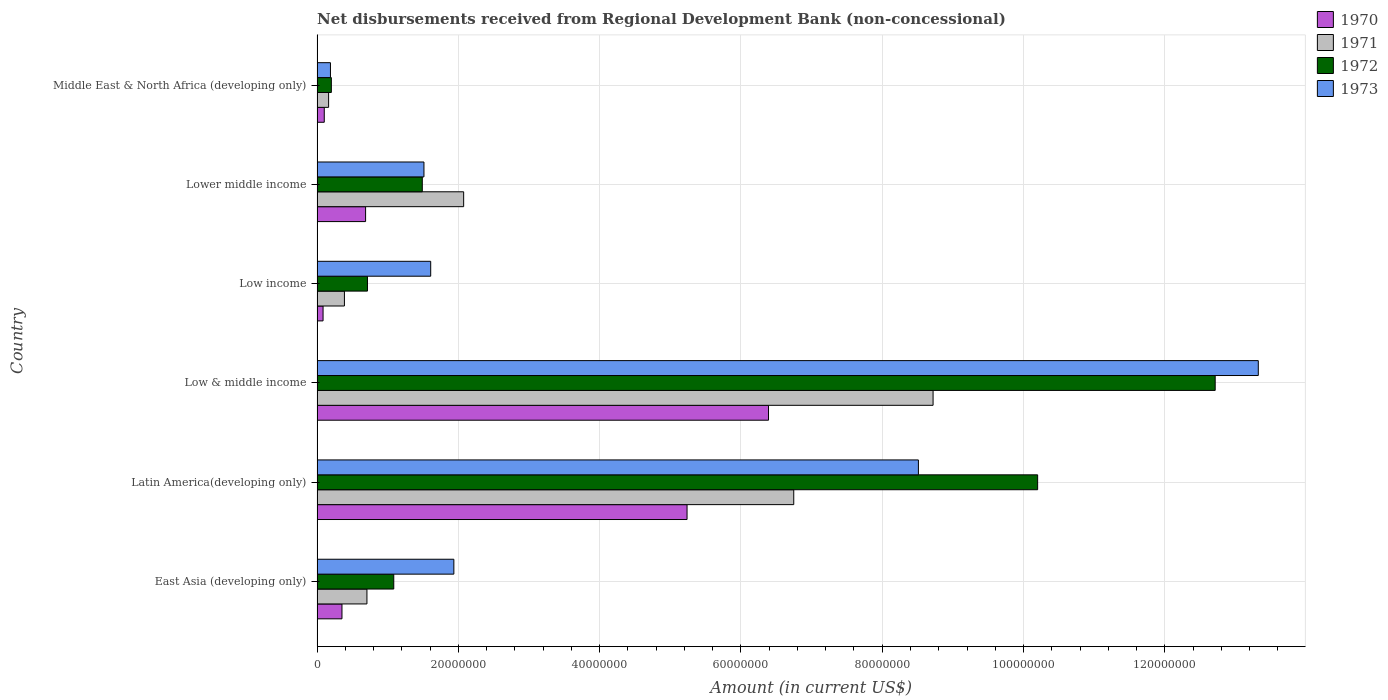How many different coloured bars are there?
Keep it short and to the point. 4. How many groups of bars are there?
Offer a terse response. 6. Are the number of bars on each tick of the Y-axis equal?
Give a very brief answer. Yes. What is the label of the 1st group of bars from the top?
Give a very brief answer. Middle East & North Africa (developing only). What is the amount of disbursements received from Regional Development Bank in 1971 in Latin America(developing only)?
Your answer should be compact. 6.75e+07. Across all countries, what is the maximum amount of disbursements received from Regional Development Bank in 1971?
Make the answer very short. 8.72e+07. Across all countries, what is the minimum amount of disbursements received from Regional Development Bank in 1972?
Ensure brevity in your answer.  2.02e+06. In which country was the amount of disbursements received from Regional Development Bank in 1972 maximum?
Offer a very short reply. Low & middle income. In which country was the amount of disbursements received from Regional Development Bank in 1972 minimum?
Your answer should be very brief. Middle East & North Africa (developing only). What is the total amount of disbursements received from Regional Development Bank in 1972 in the graph?
Provide a succinct answer. 2.64e+08. What is the difference between the amount of disbursements received from Regional Development Bank in 1971 in Low & middle income and that in Lower middle income?
Ensure brevity in your answer.  6.64e+07. What is the difference between the amount of disbursements received from Regional Development Bank in 1971 in Low income and the amount of disbursements received from Regional Development Bank in 1972 in Middle East & North Africa (developing only)?
Ensure brevity in your answer.  1.85e+06. What is the average amount of disbursements received from Regional Development Bank in 1971 per country?
Ensure brevity in your answer.  3.13e+07. What is the difference between the amount of disbursements received from Regional Development Bank in 1973 and amount of disbursements received from Regional Development Bank in 1970 in Low & middle income?
Offer a very short reply. 6.93e+07. What is the ratio of the amount of disbursements received from Regional Development Bank in 1972 in Low income to that in Lower middle income?
Your answer should be very brief. 0.48. What is the difference between the highest and the second highest amount of disbursements received from Regional Development Bank in 1972?
Give a very brief answer. 2.51e+07. What is the difference between the highest and the lowest amount of disbursements received from Regional Development Bank in 1973?
Make the answer very short. 1.31e+08. Is the sum of the amount of disbursements received from Regional Development Bank in 1973 in Low income and Lower middle income greater than the maximum amount of disbursements received from Regional Development Bank in 1970 across all countries?
Make the answer very short. No. What does the 4th bar from the top in Low & middle income represents?
Offer a terse response. 1970. What does the 2nd bar from the bottom in Low income represents?
Give a very brief answer. 1971. Is it the case that in every country, the sum of the amount of disbursements received from Regional Development Bank in 1973 and amount of disbursements received from Regional Development Bank in 1972 is greater than the amount of disbursements received from Regional Development Bank in 1970?
Your answer should be very brief. Yes. Are all the bars in the graph horizontal?
Offer a terse response. Yes. What is the difference between two consecutive major ticks on the X-axis?
Offer a very short reply. 2.00e+07. What is the title of the graph?
Offer a very short reply. Net disbursements received from Regional Development Bank (non-concessional). What is the Amount (in current US$) of 1970 in East Asia (developing only)?
Provide a short and direct response. 3.53e+06. What is the Amount (in current US$) in 1971 in East Asia (developing only)?
Provide a short and direct response. 7.06e+06. What is the Amount (in current US$) in 1972 in East Asia (developing only)?
Provide a short and direct response. 1.09e+07. What is the Amount (in current US$) of 1973 in East Asia (developing only)?
Your response must be concise. 1.94e+07. What is the Amount (in current US$) of 1970 in Latin America(developing only)?
Provide a succinct answer. 5.24e+07. What is the Amount (in current US$) of 1971 in Latin America(developing only)?
Ensure brevity in your answer.  6.75e+07. What is the Amount (in current US$) of 1972 in Latin America(developing only)?
Give a very brief answer. 1.02e+08. What is the Amount (in current US$) in 1973 in Latin America(developing only)?
Keep it short and to the point. 8.51e+07. What is the Amount (in current US$) of 1970 in Low & middle income?
Offer a very short reply. 6.39e+07. What is the Amount (in current US$) of 1971 in Low & middle income?
Offer a terse response. 8.72e+07. What is the Amount (in current US$) in 1972 in Low & middle income?
Your answer should be very brief. 1.27e+08. What is the Amount (in current US$) in 1973 in Low & middle income?
Provide a succinct answer. 1.33e+08. What is the Amount (in current US$) of 1970 in Low income?
Your answer should be very brief. 8.50e+05. What is the Amount (in current US$) in 1971 in Low income?
Ensure brevity in your answer.  3.88e+06. What is the Amount (in current US$) in 1972 in Low income?
Provide a succinct answer. 7.14e+06. What is the Amount (in current US$) of 1973 in Low income?
Offer a terse response. 1.61e+07. What is the Amount (in current US$) of 1970 in Lower middle income?
Ensure brevity in your answer.  6.87e+06. What is the Amount (in current US$) of 1971 in Lower middle income?
Offer a very short reply. 2.08e+07. What is the Amount (in current US$) in 1972 in Lower middle income?
Give a very brief answer. 1.49e+07. What is the Amount (in current US$) of 1973 in Lower middle income?
Make the answer very short. 1.51e+07. What is the Amount (in current US$) of 1970 in Middle East & North Africa (developing only)?
Give a very brief answer. 1.02e+06. What is the Amount (in current US$) of 1971 in Middle East & North Africa (developing only)?
Make the answer very short. 1.64e+06. What is the Amount (in current US$) of 1972 in Middle East & North Africa (developing only)?
Provide a succinct answer. 2.02e+06. What is the Amount (in current US$) of 1973 in Middle East & North Africa (developing only)?
Offer a very short reply. 1.90e+06. Across all countries, what is the maximum Amount (in current US$) in 1970?
Make the answer very short. 6.39e+07. Across all countries, what is the maximum Amount (in current US$) of 1971?
Offer a very short reply. 8.72e+07. Across all countries, what is the maximum Amount (in current US$) in 1972?
Provide a succinct answer. 1.27e+08. Across all countries, what is the maximum Amount (in current US$) of 1973?
Provide a short and direct response. 1.33e+08. Across all countries, what is the minimum Amount (in current US$) in 1970?
Provide a short and direct response. 8.50e+05. Across all countries, what is the minimum Amount (in current US$) in 1971?
Ensure brevity in your answer.  1.64e+06. Across all countries, what is the minimum Amount (in current US$) in 1972?
Make the answer very short. 2.02e+06. Across all countries, what is the minimum Amount (in current US$) of 1973?
Keep it short and to the point. 1.90e+06. What is the total Amount (in current US$) in 1970 in the graph?
Make the answer very short. 1.29e+08. What is the total Amount (in current US$) in 1971 in the graph?
Your answer should be very brief. 1.88e+08. What is the total Amount (in current US$) in 1972 in the graph?
Your response must be concise. 2.64e+08. What is the total Amount (in current US$) of 1973 in the graph?
Your answer should be compact. 2.71e+08. What is the difference between the Amount (in current US$) of 1970 in East Asia (developing only) and that in Latin America(developing only)?
Your answer should be very brief. -4.88e+07. What is the difference between the Amount (in current US$) of 1971 in East Asia (developing only) and that in Latin America(developing only)?
Your answer should be compact. -6.04e+07. What is the difference between the Amount (in current US$) of 1972 in East Asia (developing only) and that in Latin America(developing only)?
Your answer should be very brief. -9.11e+07. What is the difference between the Amount (in current US$) of 1973 in East Asia (developing only) and that in Latin America(developing only)?
Give a very brief answer. -6.58e+07. What is the difference between the Amount (in current US$) of 1970 in East Asia (developing only) and that in Low & middle income?
Your answer should be compact. -6.04e+07. What is the difference between the Amount (in current US$) in 1971 in East Asia (developing only) and that in Low & middle income?
Offer a very short reply. -8.01e+07. What is the difference between the Amount (in current US$) in 1972 in East Asia (developing only) and that in Low & middle income?
Your answer should be compact. -1.16e+08. What is the difference between the Amount (in current US$) of 1973 in East Asia (developing only) and that in Low & middle income?
Keep it short and to the point. -1.14e+08. What is the difference between the Amount (in current US$) of 1970 in East Asia (developing only) and that in Low income?
Give a very brief answer. 2.68e+06. What is the difference between the Amount (in current US$) in 1971 in East Asia (developing only) and that in Low income?
Offer a terse response. 3.19e+06. What is the difference between the Amount (in current US$) of 1972 in East Asia (developing only) and that in Low income?
Give a very brief answer. 3.72e+06. What is the difference between the Amount (in current US$) in 1973 in East Asia (developing only) and that in Low income?
Give a very brief answer. 3.28e+06. What is the difference between the Amount (in current US$) in 1970 in East Asia (developing only) and that in Lower middle income?
Offer a very short reply. -3.34e+06. What is the difference between the Amount (in current US$) of 1971 in East Asia (developing only) and that in Lower middle income?
Ensure brevity in your answer.  -1.37e+07. What is the difference between the Amount (in current US$) of 1972 in East Asia (developing only) and that in Lower middle income?
Your response must be concise. -4.04e+06. What is the difference between the Amount (in current US$) of 1973 in East Asia (developing only) and that in Lower middle income?
Make the answer very short. 4.23e+06. What is the difference between the Amount (in current US$) in 1970 in East Asia (developing only) and that in Middle East & North Africa (developing only)?
Your answer should be very brief. 2.51e+06. What is the difference between the Amount (in current US$) of 1971 in East Asia (developing only) and that in Middle East & North Africa (developing only)?
Keep it short and to the point. 5.43e+06. What is the difference between the Amount (in current US$) in 1972 in East Asia (developing only) and that in Middle East & North Africa (developing only)?
Provide a succinct answer. 8.83e+06. What is the difference between the Amount (in current US$) in 1973 in East Asia (developing only) and that in Middle East & North Africa (developing only)?
Ensure brevity in your answer.  1.75e+07. What is the difference between the Amount (in current US$) of 1970 in Latin America(developing only) and that in Low & middle income?
Keep it short and to the point. -1.15e+07. What is the difference between the Amount (in current US$) of 1971 in Latin America(developing only) and that in Low & middle income?
Offer a terse response. -1.97e+07. What is the difference between the Amount (in current US$) in 1972 in Latin America(developing only) and that in Low & middle income?
Your answer should be compact. -2.51e+07. What is the difference between the Amount (in current US$) in 1973 in Latin America(developing only) and that in Low & middle income?
Your answer should be very brief. -4.81e+07. What is the difference between the Amount (in current US$) in 1970 in Latin America(developing only) and that in Low income?
Offer a very short reply. 5.15e+07. What is the difference between the Amount (in current US$) of 1971 in Latin America(developing only) and that in Low income?
Your answer should be compact. 6.36e+07. What is the difference between the Amount (in current US$) in 1972 in Latin America(developing only) and that in Low income?
Your answer should be very brief. 9.49e+07. What is the difference between the Amount (in current US$) in 1973 in Latin America(developing only) and that in Low income?
Give a very brief answer. 6.90e+07. What is the difference between the Amount (in current US$) of 1970 in Latin America(developing only) and that in Lower middle income?
Provide a short and direct response. 4.55e+07. What is the difference between the Amount (in current US$) in 1971 in Latin America(developing only) and that in Lower middle income?
Offer a very short reply. 4.67e+07. What is the difference between the Amount (in current US$) in 1972 in Latin America(developing only) and that in Lower middle income?
Ensure brevity in your answer.  8.71e+07. What is the difference between the Amount (in current US$) in 1973 in Latin America(developing only) and that in Lower middle income?
Give a very brief answer. 7.00e+07. What is the difference between the Amount (in current US$) of 1970 in Latin America(developing only) and that in Middle East & North Africa (developing only)?
Keep it short and to the point. 5.14e+07. What is the difference between the Amount (in current US$) in 1971 in Latin America(developing only) and that in Middle East & North Africa (developing only)?
Provide a short and direct response. 6.58e+07. What is the difference between the Amount (in current US$) in 1972 in Latin America(developing only) and that in Middle East & North Africa (developing only)?
Your answer should be very brief. 1.00e+08. What is the difference between the Amount (in current US$) in 1973 in Latin America(developing only) and that in Middle East & North Africa (developing only)?
Your answer should be compact. 8.32e+07. What is the difference between the Amount (in current US$) in 1970 in Low & middle income and that in Low income?
Make the answer very short. 6.31e+07. What is the difference between the Amount (in current US$) of 1971 in Low & middle income and that in Low income?
Give a very brief answer. 8.33e+07. What is the difference between the Amount (in current US$) of 1972 in Low & middle income and that in Low income?
Provide a succinct answer. 1.20e+08. What is the difference between the Amount (in current US$) in 1973 in Low & middle income and that in Low income?
Your answer should be very brief. 1.17e+08. What is the difference between the Amount (in current US$) in 1970 in Low & middle income and that in Lower middle income?
Keep it short and to the point. 5.70e+07. What is the difference between the Amount (in current US$) in 1971 in Low & middle income and that in Lower middle income?
Keep it short and to the point. 6.64e+07. What is the difference between the Amount (in current US$) of 1972 in Low & middle income and that in Lower middle income?
Give a very brief answer. 1.12e+08. What is the difference between the Amount (in current US$) in 1973 in Low & middle income and that in Lower middle income?
Your answer should be very brief. 1.18e+08. What is the difference between the Amount (in current US$) in 1970 in Low & middle income and that in Middle East & North Africa (developing only)?
Offer a terse response. 6.29e+07. What is the difference between the Amount (in current US$) of 1971 in Low & middle income and that in Middle East & North Africa (developing only)?
Provide a succinct answer. 8.56e+07. What is the difference between the Amount (in current US$) in 1972 in Low & middle income and that in Middle East & North Africa (developing only)?
Offer a very short reply. 1.25e+08. What is the difference between the Amount (in current US$) in 1973 in Low & middle income and that in Middle East & North Africa (developing only)?
Your response must be concise. 1.31e+08. What is the difference between the Amount (in current US$) of 1970 in Low income and that in Lower middle income?
Provide a short and direct response. -6.02e+06. What is the difference between the Amount (in current US$) in 1971 in Low income and that in Lower middle income?
Provide a succinct answer. -1.69e+07. What is the difference between the Amount (in current US$) of 1972 in Low income and that in Lower middle income?
Ensure brevity in your answer.  -7.76e+06. What is the difference between the Amount (in current US$) of 1973 in Low income and that in Lower middle income?
Provide a succinct answer. 9.55e+05. What is the difference between the Amount (in current US$) in 1970 in Low income and that in Middle East & North Africa (developing only)?
Give a very brief answer. -1.71e+05. What is the difference between the Amount (in current US$) in 1971 in Low income and that in Middle East & North Africa (developing only)?
Offer a terse response. 2.24e+06. What is the difference between the Amount (in current US$) of 1972 in Low income and that in Middle East & North Africa (developing only)?
Offer a terse response. 5.11e+06. What is the difference between the Amount (in current US$) of 1973 in Low income and that in Middle East & North Africa (developing only)?
Provide a short and direct response. 1.42e+07. What is the difference between the Amount (in current US$) of 1970 in Lower middle income and that in Middle East & North Africa (developing only)?
Make the answer very short. 5.85e+06. What is the difference between the Amount (in current US$) in 1971 in Lower middle income and that in Middle East & North Africa (developing only)?
Give a very brief answer. 1.91e+07. What is the difference between the Amount (in current US$) in 1972 in Lower middle income and that in Middle East & North Africa (developing only)?
Your response must be concise. 1.29e+07. What is the difference between the Amount (in current US$) in 1973 in Lower middle income and that in Middle East & North Africa (developing only)?
Provide a short and direct response. 1.32e+07. What is the difference between the Amount (in current US$) in 1970 in East Asia (developing only) and the Amount (in current US$) in 1971 in Latin America(developing only)?
Your response must be concise. -6.39e+07. What is the difference between the Amount (in current US$) of 1970 in East Asia (developing only) and the Amount (in current US$) of 1972 in Latin America(developing only)?
Keep it short and to the point. -9.85e+07. What is the difference between the Amount (in current US$) of 1970 in East Asia (developing only) and the Amount (in current US$) of 1973 in Latin America(developing only)?
Your answer should be very brief. -8.16e+07. What is the difference between the Amount (in current US$) of 1971 in East Asia (developing only) and the Amount (in current US$) of 1972 in Latin America(developing only)?
Your answer should be very brief. -9.49e+07. What is the difference between the Amount (in current US$) of 1971 in East Asia (developing only) and the Amount (in current US$) of 1973 in Latin America(developing only)?
Your answer should be very brief. -7.81e+07. What is the difference between the Amount (in current US$) in 1972 in East Asia (developing only) and the Amount (in current US$) in 1973 in Latin America(developing only)?
Your answer should be very brief. -7.43e+07. What is the difference between the Amount (in current US$) in 1970 in East Asia (developing only) and the Amount (in current US$) in 1971 in Low & middle income?
Your answer should be compact. -8.37e+07. What is the difference between the Amount (in current US$) in 1970 in East Asia (developing only) and the Amount (in current US$) in 1972 in Low & middle income?
Offer a terse response. -1.24e+08. What is the difference between the Amount (in current US$) in 1970 in East Asia (developing only) and the Amount (in current US$) in 1973 in Low & middle income?
Your response must be concise. -1.30e+08. What is the difference between the Amount (in current US$) in 1971 in East Asia (developing only) and the Amount (in current US$) in 1972 in Low & middle income?
Keep it short and to the point. -1.20e+08. What is the difference between the Amount (in current US$) of 1971 in East Asia (developing only) and the Amount (in current US$) of 1973 in Low & middle income?
Your answer should be compact. -1.26e+08. What is the difference between the Amount (in current US$) in 1972 in East Asia (developing only) and the Amount (in current US$) in 1973 in Low & middle income?
Give a very brief answer. -1.22e+08. What is the difference between the Amount (in current US$) of 1970 in East Asia (developing only) and the Amount (in current US$) of 1971 in Low income?
Make the answer very short. -3.48e+05. What is the difference between the Amount (in current US$) in 1970 in East Asia (developing only) and the Amount (in current US$) in 1972 in Low income?
Ensure brevity in your answer.  -3.61e+06. What is the difference between the Amount (in current US$) of 1970 in East Asia (developing only) and the Amount (in current US$) of 1973 in Low income?
Give a very brief answer. -1.26e+07. What is the difference between the Amount (in current US$) in 1971 in East Asia (developing only) and the Amount (in current US$) in 1972 in Low income?
Offer a terse response. -7.50e+04. What is the difference between the Amount (in current US$) in 1971 in East Asia (developing only) and the Amount (in current US$) in 1973 in Low income?
Provide a short and direct response. -9.03e+06. What is the difference between the Amount (in current US$) of 1972 in East Asia (developing only) and the Amount (in current US$) of 1973 in Low income?
Provide a short and direct response. -5.23e+06. What is the difference between the Amount (in current US$) in 1970 in East Asia (developing only) and the Amount (in current US$) in 1971 in Lower middle income?
Offer a terse response. -1.72e+07. What is the difference between the Amount (in current US$) of 1970 in East Asia (developing only) and the Amount (in current US$) of 1972 in Lower middle income?
Provide a succinct answer. -1.14e+07. What is the difference between the Amount (in current US$) in 1970 in East Asia (developing only) and the Amount (in current US$) in 1973 in Lower middle income?
Give a very brief answer. -1.16e+07. What is the difference between the Amount (in current US$) of 1971 in East Asia (developing only) and the Amount (in current US$) of 1972 in Lower middle income?
Ensure brevity in your answer.  -7.84e+06. What is the difference between the Amount (in current US$) of 1971 in East Asia (developing only) and the Amount (in current US$) of 1973 in Lower middle income?
Offer a very short reply. -8.07e+06. What is the difference between the Amount (in current US$) of 1972 in East Asia (developing only) and the Amount (in current US$) of 1973 in Lower middle income?
Your response must be concise. -4.28e+06. What is the difference between the Amount (in current US$) in 1970 in East Asia (developing only) and the Amount (in current US$) in 1971 in Middle East & North Africa (developing only)?
Make the answer very short. 1.89e+06. What is the difference between the Amount (in current US$) of 1970 in East Asia (developing only) and the Amount (in current US$) of 1972 in Middle East & North Africa (developing only)?
Make the answer very short. 1.50e+06. What is the difference between the Amount (in current US$) of 1970 in East Asia (developing only) and the Amount (in current US$) of 1973 in Middle East & North Africa (developing only)?
Give a very brief answer. 1.63e+06. What is the difference between the Amount (in current US$) in 1971 in East Asia (developing only) and the Amount (in current US$) in 1972 in Middle East & North Africa (developing only)?
Your answer should be compact. 5.04e+06. What is the difference between the Amount (in current US$) in 1971 in East Asia (developing only) and the Amount (in current US$) in 1973 in Middle East & North Africa (developing only)?
Give a very brief answer. 5.17e+06. What is the difference between the Amount (in current US$) of 1972 in East Asia (developing only) and the Amount (in current US$) of 1973 in Middle East & North Africa (developing only)?
Give a very brief answer. 8.96e+06. What is the difference between the Amount (in current US$) in 1970 in Latin America(developing only) and the Amount (in current US$) in 1971 in Low & middle income?
Provide a short and direct response. -3.48e+07. What is the difference between the Amount (in current US$) in 1970 in Latin America(developing only) and the Amount (in current US$) in 1972 in Low & middle income?
Give a very brief answer. -7.48e+07. What is the difference between the Amount (in current US$) in 1970 in Latin America(developing only) and the Amount (in current US$) in 1973 in Low & middle income?
Give a very brief answer. -8.09e+07. What is the difference between the Amount (in current US$) in 1971 in Latin America(developing only) and the Amount (in current US$) in 1972 in Low & middle income?
Offer a terse response. -5.97e+07. What is the difference between the Amount (in current US$) in 1971 in Latin America(developing only) and the Amount (in current US$) in 1973 in Low & middle income?
Offer a very short reply. -6.58e+07. What is the difference between the Amount (in current US$) in 1972 in Latin America(developing only) and the Amount (in current US$) in 1973 in Low & middle income?
Make the answer very short. -3.12e+07. What is the difference between the Amount (in current US$) of 1970 in Latin America(developing only) and the Amount (in current US$) of 1971 in Low income?
Make the answer very short. 4.85e+07. What is the difference between the Amount (in current US$) of 1970 in Latin America(developing only) and the Amount (in current US$) of 1972 in Low income?
Offer a terse response. 4.52e+07. What is the difference between the Amount (in current US$) in 1970 in Latin America(developing only) and the Amount (in current US$) in 1973 in Low income?
Your answer should be very brief. 3.63e+07. What is the difference between the Amount (in current US$) of 1971 in Latin America(developing only) and the Amount (in current US$) of 1972 in Low income?
Your response must be concise. 6.03e+07. What is the difference between the Amount (in current US$) in 1971 in Latin America(developing only) and the Amount (in current US$) in 1973 in Low income?
Offer a terse response. 5.14e+07. What is the difference between the Amount (in current US$) in 1972 in Latin America(developing only) and the Amount (in current US$) in 1973 in Low income?
Your response must be concise. 8.59e+07. What is the difference between the Amount (in current US$) in 1970 in Latin America(developing only) and the Amount (in current US$) in 1971 in Lower middle income?
Ensure brevity in your answer.  3.16e+07. What is the difference between the Amount (in current US$) of 1970 in Latin America(developing only) and the Amount (in current US$) of 1972 in Lower middle income?
Your response must be concise. 3.75e+07. What is the difference between the Amount (in current US$) of 1970 in Latin America(developing only) and the Amount (in current US$) of 1973 in Lower middle income?
Your answer should be compact. 3.72e+07. What is the difference between the Amount (in current US$) in 1971 in Latin America(developing only) and the Amount (in current US$) in 1972 in Lower middle income?
Provide a short and direct response. 5.26e+07. What is the difference between the Amount (in current US$) of 1971 in Latin America(developing only) and the Amount (in current US$) of 1973 in Lower middle income?
Keep it short and to the point. 5.23e+07. What is the difference between the Amount (in current US$) in 1972 in Latin America(developing only) and the Amount (in current US$) in 1973 in Lower middle income?
Offer a very short reply. 8.69e+07. What is the difference between the Amount (in current US$) in 1970 in Latin America(developing only) and the Amount (in current US$) in 1971 in Middle East & North Africa (developing only)?
Offer a terse response. 5.07e+07. What is the difference between the Amount (in current US$) in 1970 in Latin America(developing only) and the Amount (in current US$) in 1972 in Middle East & North Africa (developing only)?
Make the answer very short. 5.04e+07. What is the difference between the Amount (in current US$) in 1970 in Latin America(developing only) and the Amount (in current US$) in 1973 in Middle East & North Africa (developing only)?
Give a very brief answer. 5.05e+07. What is the difference between the Amount (in current US$) of 1971 in Latin America(developing only) and the Amount (in current US$) of 1972 in Middle East & North Africa (developing only)?
Offer a very short reply. 6.55e+07. What is the difference between the Amount (in current US$) of 1971 in Latin America(developing only) and the Amount (in current US$) of 1973 in Middle East & North Africa (developing only)?
Ensure brevity in your answer.  6.56e+07. What is the difference between the Amount (in current US$) of 1972 in Latin America(developing only) and the Amount (in current US$) of 1973 in Middle East & North Africa (developing only)?
Make the answer very short. 1.00e+08. What is the difference between the Amount (in current US$) of 1970 in Low & middle income and the Amount (in current US$) of 1971 in Low income?
Provide a short and direct response. 6.00e+07. What is the difference between the Amount (in current US$) of 1970 in Low & middle income and the Amount (in current US$) of 1972 in Low income?
Your response must be concise. 5.68e+07. What is the difference between the Amount (in current US$) of 1970 in Low & middle income and the Amount (in current US$) of 1973 in Low income?
Offer a terse response. 4.78e+07. What is the difference between the Amount (in current US$) in 1971 in Low & middle income and the Amount (in current US$) in 1972 in Low income?
Offer a very short reply. 8.01e+07. What is the difference between the Amount (in current US$) in 1971 in Low & middle income and the Amount (in current US$) in 1973 in Low income?
Provide a succinct answer. 7.11e+07. What is the difference between the Amount (in current US$) in 1972 in Low & middle income and the Amount (in current US$) in 1973 in Low income?
Make the answer very short. 1.11e+08. What is the difference between the Amount (in current US$) in 1970 in Low & middle income and the Amount (in current US$) in 1971 in Lower middle income?
Provide a short and direct response. 4.32e+07. What is the difference between the Amount (in current US$) in 1970 in Low & middle income and the Amount (in current US$) in 1972 in Lower middle income?
Offer a terse response. 4.90e+07. What is the difference between the Amount (in current US$) in 1970 in Low & middle income and the Amount (in current US$) in 1973 in Lower middle income?
Offer a terse response. 4.88e+07. What is the difference between the Amount (in current US$) of 1971 in Low & middle income and the Amount (in current US$) of 1972 in Lower middle income?
Keep it short and to the point. 7.23e+07. What is the difference between the Amount (in current US$) of 1971 in Low & middle income and the Amount (in current US$) of 1973 in Lower middle income?
Make the answer very short. 7.21e+07. What is the difference between the Amount (in current US$) of 1972 in Low & middle income and the Amount (in current US$) of 1973 in Lower middle income?
Your answer should be compact. 1.12e+08. What is the difference between the Amount (in current US$) in 1970 in Low & middle income and the Amount (in current US$) in 1971 in Middle East & North Africa (developing only)?
Your response must be concise. 6.23e+07. What is the difference between the Amount (in current US$) in 1970 in Low & middle income and the Amount (in current US$) in 1972 in Middle East & North Africa (developing only)?
Your response must be concise. 6.19e+07. What is the difference between the Amount (in current US$) of 1970 in Low & middle income and the Amount (in current US$) of 1973 in Middle East & North Africa (developing only)?
Offer a terse response. 6.20e+07. What is the difference between the Amount (in current US$) of 1971 in Low & middle income and the Amount (in current US$) of 1972 in Middle East & North Africa (developing only)?
Ensure brevity in your answer.  8.52e+07. What is the difference between the Amount (in current US$) of 1971 in Low & middle income and the Amount (in current US$) of 1973 in Middle East & North Africa (developing only)?
Your answer should be compact. 8.53e+07. What is the difference between the Amount (in current US$) of 1972 in Low & middle income and the Amount (in current US$) of 1973 in Middle East & North Africa (developing only)?
Offer a very short reply. 1.25e+08. What is the difference between the Amount (in current US$) in 1970 in Low income and the Amount (in current US$) in 1971 in Lower middle income?
Give a very brief answer. -1.99e+07. What is the difference between the Amount (in current US$) of 1970 in Low income and the Amount (in current US$) of 1972 in Lower middle income?
Your answer should be very brief. -1.40e+07. What is the difference between the Amount (in current US$) in 1970 in Low income and the Amount (in current US$) in 1973 in Lower middle income?
Offer a very short reply. -1.43e+07. What is the difference between the Amount (in current US$) of 1971 in Low income and the Amount (in current US$) of 1972 in Lower middle income?
Make the answer very short. -1.10e+07. What is the difference between the Amount (in current US$) in 1971 in Low income and the Amount (in current US$) in 1973 in Lower middle income?
Keep it short and to the point. -1.13e+07. What is the difference between the Amount (in current US$) of 1972 in Low income and the Amount (in current US$) of 1973 in Lower middle income?
Ensure brevity in your answer.  -8.00e+06. What is the difference between the Amount (in current US$) in 1970 in Low income and the Amount (in current US$) in 1971 in Middle East & North Africa (developing only)?
Ensure brevity in your answer.  -7.85e+05. What is the difference between the Amount (in current US$) in 1970 in Low income and the Amount (in current US$) in 1972 in Middle East & North Africa (developing only)?
Provide a succinct answer. -1.17e+06. What is the difference between the Amount (in current US$) in 1970 in Low income and the Amount (in current US$) in 1973 in Middle East & North Africa (developing only)?
Ensure brevity in your answer.  -1.05e+06. What is the difference between the Amount (in current US$) in 1971 in Low income and the Amount (in current US$) in 1972 in Middle East & North Africa (developing only)?
Offer a terse response. 1.85e+06. What is the difference between the Amount (in current US$) in 1971 in Low income and the Amount (in current US$) in 1973 in Middle East & North Africa (developing only)?
Ensure brevity in your answer.  1.98e+06. What is the difference between the Amount (in current US$) in 1972 in Low income and the Amount (in current US$) in 1973 in Middle East & North Africa (developing only)?
Keep it short and to the point. 5.24e+06. What is the difference between the Amount (in current US$) in 1970 in Lower middle income and the Amount (in current US$) in 1971 in Middle East & North Africa (developing only)?
Make the answer very short. 5.24e+06. What is the difference between the Amount (in current US$) in 1970 in Lower middle income and the Amount (in current US$) in 1972 in Middle East & North Africa (developing only)?
Provide a succinct answer. 4.85e+06. What is the difference between the Amount (in current US$) of 1970 in Lower middle income and the Amount (in current US$) of 1973 in Middle East & North Africa (developing only)?
Keep it short and to the point. 4.98e+06. What is the difference between the Amount (in current US$) of 1971 in Lower middle income and the Amount (in current US$) of 1972 in Middle East & North Africa (developing only)?
Your response must be concise. 1.87e+07. What is the difference between the Amount (in current US$) of 1971 in Lower middle income and the Amount (in current US$) of 1973 in Middle East & North Africa (developing only)?
Provide a short and direct response. 1.89e+07. What is the difference between the Amount (in current US$) of 1972 in Lower middle income and the Amount (in current US$) of 1973 in Middle East & North Africa (developing only)?
Keep it short and to the point. 1.30e+07. What is the average Amount (in current US$) of 1970 per country?
Provide a short and direct response. 2.14e+07. What is the average Amount (in current US$) in 1971 per country?
Your answer should be compact. 3.13e+07. What is the average Amount (in current US$) in 1972 per country?
Provide a short and direct response. 4.40e+07. What is the average Amount (in current US$) in 1973 per country?
Your answer should be compact. 4.51e+07. What is the difference between the Amount (in current US$) of 1970 and Amount (in current US$) of 1971 in East Asia (developing only)?
Your answer should be compact. -3.54e+06. What is the difference between the Amount (in current US$) of 1970 and Amount (in current US$) of 1972 in East Asia (developing only)?
Provide a short and direct response. -7.33e+06. What is the difference between the Amount (in current US$) in 1970 and Amount (in current US$) in 1973 in East Asia (developing only)?
Give a very brief answer. -1.58e+07. What is the difference between the Amount (in current US$) in 1971 and Amount (in current US$) in 1972 in East Asia (developing only)?
Provide a succinct answer. -3.80e+06. What is the difference between the Amount (in current US$) of 1971 and Amount (in current US$) of 1973 in East Asia (developing only)?
Give a very brief answer. -1.23e+07. What is the difference between the Amount (in current US$) of 1972 and Amount (in current US$) of 1973 in East Asia (developing only)?
Offer a very short reply. -8.51e+06. What is the difference between the Amount (in current US$) of 1970 and Amount (in current US$) of 1971 in Latin America(developing only)?
Offer a terse response. -1.51e+07. What is the difference between the Amount (in current US$) in 1970 and Amount (in current US$) in 1972 in Latin America(developing only)?
Ensure brevity in your answer.  -4.96e+07. What is the difference between the Amount (in current US$) of 1970 and Amount (in current US$) of 1973 in Latin America(developing only)?
Your response must be concise. -3.27e+07. What is the difference between the Amount (in current US$) of 1971 and Amount (in current US$) of 1972 in Latin America(developing only)?
Make the answer very short. -3.45e+07. What is the difference between the Amount (in current US$) of 1971 and Amount (in current US$) of 1973 in Latin America(developing only)?
Ensure brevity in your answer.  -1.76e+07. What is the difference between the Amount (in current US$) in 1972 and Amount (in current US$) in 1973 in Latin America(developing only)?
Provide a short and direct response. 1.69e+07. What is the difference between the Amount (in current US$) in 1970 and Amount (in current US$) in 1971 in Low & middle income?
Offer a terse response. -2.33e+07. What is the difference between the Amount (in current US$) in 1970 and Amount (in current US$) in 1972 in Low & middle income?
Offer a terse response. -6.32e+07. What is the difference between the Amount (in current US$) in 1970 and Amount (in current US$) in 1973 in Low & middle income?
Your answer should be very brief. -6.93e+07. What is the difference between the Amount (in current US$) in 1971 and Amount (in current US$) in 1972 in Low & middle income?
Make the answer very short. -3.99e+07. What is the difference between the Amount (in current US$) in 1971 and Amount (in current US$) in 1973 in Low & middle income?
Ensure brevity in your answer.  -4.60e+07. What is the difference between the Amount (in current US$) of 1972 and Amount (in current US$) of 1973 in Low & middle income?
Ensure brevity in your answer.  -6.10e+06. What is the difference between the Amount (in current US$) of 1970 and Amount (in current US$) of 1971 in Low income?
Ensure brevity in your answer.  -3.02e+06. What is the difference between the Amount (in current US$) in 1970 and Amount (in current US$) in 1972 in Low income?
Your answer should be compact. -6.29e+06. What is the difference between the Amount (in current US$) of 1970 and Amount (in current US$) of 1973 in Low income?
Your answer should be compact. -1.52e+07. What is the difference between the Amount (in current US$) in 1971 and Amount (in current US$) in 1972 in Low income?
Your answer should be very brief. -3.26e+06. What is the difference between the Amount (in current US$) in 1971 and Amount (in current US$) in 1973 in Low income?
Provide a short and direct response. -1.22e+07. What is the difference between the Amount (in current US$) of 1972 and Amount (in current US$) of 1973 in Low income?
Offer a terse response. -8.95e+06. What is the difference between the Amount (in current US$) of 1970 and Amount (in current US$) of 1971 in Lower middle income?
Ensure brevity in your answer.  -1.39e+07. What is the difference between the Amount (in current US$) of 1970 and Amount (in current US$) of 1972 in Lower middle income?
Provide a short and direct response. -8.03e+06. What is the difference between the Amount (in current US$) in 1970 and Amount (in current US$) in 1973 in Lower middle income?
Provide a succinct answer. -8.26e+06. What is the difference between the Amount (in current US$) of 1971 and Amount (in current US$) of 1972 in Lower middle income?
Your response must be concise. 5.85e+06. What is the difference between the Amount (in current US$) in 1971 and Amount (in current US$) in 1973 in Lower middle income?
Provide a succinct answer. 5.62e+06. What is the difference between the Amount (in current US$) in 1972 and Amount (in current US$) in 1973 in Lower middle income?
Your response must be concise. -2.36e+05. What is the difference between the Amount (in current US$) of 1970 and Amount (in current US$) of 1971 in Middle East & North Africa (developing only)?
Your answer should be very brief. -6.14e+05. What is the difference between the Amount (in current US$) of 1970 and Amount (in current US$) of 1972 in Middle East & North Africa (developing only)?
Provide a short and direct response. -1.00e+06. What is the difference between the Amount (in current US$) of 1970 and Amount (in current US$) of 1973 in Middle East & North Africa (developing only)?
Your answer should be compact. -8.75e+05. What is the difference between the Amount (in current US$) of 1971 and Amount (in current US$) of 1972 in Middle East & North Africa (developing only)?
Give a very brief answer. -3.89e+05. What is the difference between the Amount (in current US$) of 1971 and Amount (in current US$) of 1973 in Middle East & North Africa (developing only)?
Offer a terse response. -2.61e+05. What is the difference between the Amount (in current US$) in 1972 and Amount (in current US$) in 1973 in Middle East & North Africa (developing only)?
Give a very brief answer. 1.28e+05. What is the ratio of the Amount (in current US$) of 1970 in East Asia (developing only) to that in Latin America(developing only)?
Keep it short and to the point. 0.07. What is the ratio of the Amount (in current US$) of 1971 in East Asia (developing only) to that in Latin America(developing only)?
Your answer should be very brief. 0.1. What is the ratio of the Amount (in current US$) in 1972 in East Asia (developing only) to that in Latin America(developing only)?
Your answer should be very brief. 0.11. What is the ratio of the Amount (in current US$) of 1973 in East Asia (developing only) to that in Latin America(developing only)?
Provide a short and direct response. 0.23. What is the ratio of the Amount (in current US$) in 1970 in East Asia (developing only) to that in Low & middle income?
Offer a very short reply. 0.06. What is the ratio of the Amount (in current US$) of 1971 in East Asia (developing only) to that in Low & middle income?
Provide a short and direct response. 0.08. What is the ratio of the Amount (in current US$) in 1972 in East Asia (developing only) to that in Low & middle income?
Your response must be concise. 0.09. What is the ratio of the Amount (in current US$) of 1973 in East Asia (developing only) to that in Low & middle income?
Offer a terse response. 0.15. What is the ratio of the Amount (in current US$) of 1970 in East Asia (developing only) to that in Low income?
Give a very brief answer. 4.15. What is the ratio of the Amount (in current US$) of 1971 in East Asia (developing only) to that in Low income?
Offer a very short reply. 1.82. What is the ratio of the Amount (in current US$) of 1972 in East Asia (developing only) to that in Low income?
Provide a succinct answer. 1.52. What is the ratio of the Amount (in current US$) of 1973 in East Asia (developing only) to that in Low income?
Make the answer very short. 1.2. What is the ratio of the Amount (in current US$) in 1970 in East Asia (developing only) to that in Lower middle income?
Provide a succinct answer. 0.51. What is the ratio of the Amount (in current US$) in 1971 in East Asia (developing only) to that in Lower middle income?
Give a very brief answer. 0.34. What is the ratio of the Amount (in current US$) in 1972 in East Asia (developing only) to that in Lower middle income?
Your answer should be compact. 0.73. What is the ratio of the Amount (in current US$) of 1973 in East Asia (developing only) to that in Lower middle income?
Offer a very short reply. 1.28. What is the ratio of the Amount (in current US$) in 1970 in East Asia (developing only) to that in Middle East & North Africa (developing only)?
Offer a very short reply. 3.45. What is the ratio of the Amount (in current US$) in 1971 in East Asia (developing only) to that in Middle East & North Africa (developing only)?
Provide a succinct answer. 4.32. What is the ratio of the Amount (in current US$) of 1972 in East Asia (developing only) to that in Middle East & North Africa (developing only)?
Give a very brief answer. 5.36. What is the ratio of the Amount (in current US$) of 1973 in East Asia (developing only) to that in Middle East & North Africa (developing only)?
Make the answer very short. 10.21. What is the ratio of the Amount (in current US$) in 1970 in Latin America(developing only) to that in Low & middle income?
Your response must be concise. 0.82. What is the ratio of the Amount (in current US$) of 1971 in Latin America(developing only) to that in Low & middle income?
Make the answer very short. 0.77. What is the ratio of the Amount (in current US$) of 1972 in Latin America(developing only) to that in Low & middle income?
Keep it short and to the point. 0.8. What is the ratio of the Amount (in current US$) in 1973 in Latin America(developing only) to that in Low & middle income?
Keep it short and to the point. 0.64. What is the ratio of the Amount (in current US$) of 1970 in Latin America(developing only) to that in Low income?
Your answer should be very brief. 61.62. What is the ratio of the Amount (in current US$) in 1971 in Latin America(developing only) to that in Low income?
Offer a terse response. 17.41. What is the ratio of the Amount (in current US$) of 1972 in Latin America(developing only) to that in Low income?
Your response must be concise. 14.29. What is the ratio of the Amount (in current US$) of 1973 in Latin America(developing only) to that in Low income?
Give a very brief answer. 5.29. What is the ratio of the Amount (in current US$) of 1970 in Latin America(developing only) to that in Lower middle income?
Offer a terse response. 7.62. What is the ratio of the Amount (in current US$) in 1971 in Latin America(developing only) to that in Lower middle income?
Provide a short and direct response. 3.25. What is the ratio of the Amount (in current US$) in 1972 in Latin America(developing only) to that in Lower middle income?
Offer a terse response. 6.85. What is the ratio of the Amount (in current US$) of 1973 in Latin America(developing only) to that in Lower middle income?
Your answer should be compact. 5.62. What is the ratio of the Amount (in current US$) of 1970 in Latin America(developing only) to that in Middle East & North Africa (developing only)?
Provide a succinct answer. 51.3. What is the ratio of the Amount (in current US$) in 1971 in Latin America(developing only) to that in Middle East & North Africa (developing only)?
Provide a succinct answer. 41.27. What is the ratio of the Amount (in current US$) in 1972 in Latin America(developing only) to that in Middle East & North Africa (developing only)?
Give a very brief answer. 50.4. What is the ratio of the Amount (in current US$) of 1973 in Latin America(developing only) to that in Middle East & North Africa (developing only)?
Your response must be concise. 44.9. What is the ratio of the Amount (in current US$) in 1970 in Low & middle income to that in Low income?
Your answer should be very brief. 75.18. What is the ratio of the Amount (in current US$) in 1971 in Low & middle income to that in Low income?
Make the answer very short. 22.5. What is the ratio of the Amount (in current US$) in 1972 in Low & middle income to that in Low income?
Keep it short and to the point. 17.81. What is the ratio of the Amount (in current US$) in 1973 in Low & middle income to that in Low income?
Your response must be concise. 8.28. What is the ratio of the Amount (in current US$) of 1970 in Low & middle income to that in Lower middle income?
Give a very brief answer. 9.3. What is the ratio of the Amount (in current US$) in 1971 in Low & middle income to that in Lower middle income?
Your answer should be compact. 4.2. What is the ratio of the Amount (in current US$) in 1972 in Low & middle income to that in Lower middle income?
Give a very brief answer. 8.53. What is the ratio of the Amount (in current US$) of 1973 in Low & middle income to that in Lower middle income?
Ensure brevity in your answer.  8.8. What is the ratio of the Amount (in current US$) of 1970 in Low & middle income to that in Middle East & North Africa (developing only)?
Give a very brief answer. 62.59. What is the ratio of the Amount (in current US$) of 1971 in Low & middle income to that in Middle East & North Africa (developing only)?
Your response must be concise. 53.33. What is the ratio of the Amount (in current US$) in 1972 in Low & middle income to that in Middle East & North Africa (developing only)?
Keep it short and to the point. 62.81. What is the ratio of the Amount (in current US$) in 1973 in Low & middle income to that in Middle East & North Africa (developing only)?
Provide a short and direct response. 70.27. What is the ratio of the Amount (in current US$) of 1970 in Low income to that in Lower middle income?
Offer a very short reply. 0.12. What is the ratio of the Amount (in current US$) in 1971 in Low income to that in Lower middle income?
Your answer should be compact. 0.19. What is the ratio of the Amount (in current US$) in 1972 in Low income to that in Lower middle income?
Offer a terse response. 0.48. What is the ratio of the Amount (in current US$) in 1973 in Low income to that in Lower middle income?
Offer a very short reply. 1.06. What is the ratio of the Amount (in current US$) of 1970 in Low income to that in Middle East & North Africa (developing only)?
Provide a succinct answer. 0.83. What is the ratio of the Amount (in current US$) of 1971 in Low income to that in Middle East & North Africa (developing only)?
Make the answer very short. 2.37. What is the ratio of the Amount (in current US$) in 1972 in Low income to that in Middle East & North Africa (developing only)?
Provide a short and direct response. 3.53. What is the ratio of the Amount (in current US$) of 1973 in Low income to that in Middle East & North Africa (developing only)?
Your answer should be compact. 8.49. What is the ratio of the Amount (in current US$) in 1970 in Lower middle income to that in Middle East & North Africa (developing only)?
Offer a very short reply. 6.73. What is the ratio of the Amount (in current US$) of 1971 in Lower middle income to that in Middle East & North Africa (developing only)?
Make the answer very short. 12.69. What is the ratio of the Amount (in current US$) of 1972 in Lower middle income to that in Middle East & North Africa (developing only)?
Offer a terse response. 7.36. What is the ratio of the Amount (in current US$) of 1973 in Lower middle income to that in Middle East & North Africa (developing only)?
Ensure brevity in your answer.  7.98. What is the difference between the highest and the second highest Amount (in current US$) in 1970?
Offer a terse response. 1.15e+07. What is the difference between the highest and the second highest Amount (in current US$) in 1971?
Offer a very short reply. 1.97e+07. What is the difference between the highest and the second highest Amount (in current US$) in 1972?
Your answer should be very brief. 2.51e+07. What is the difference between the highest and the second highest Amount (in current US$) in 1973?
Offer a very short reply. 4.81e+07. What is the difference between the highest and the lowest Amount (in current US$) in 1970?
Make the answer very short. 6.31e+07. What is the difference between the highest and the lowest Amount (in current US$) in 1971?
Offer a very short reply. 8.56e+07. What is the difference between the highest and the lowest Amount (in current US$) in 1972?
Keep it short and to the point. 1.25e+08. What is the difference between the highest and the lowest Amount (in current US$) of 1973?
Offer a very short reply. 1.31e+08. 